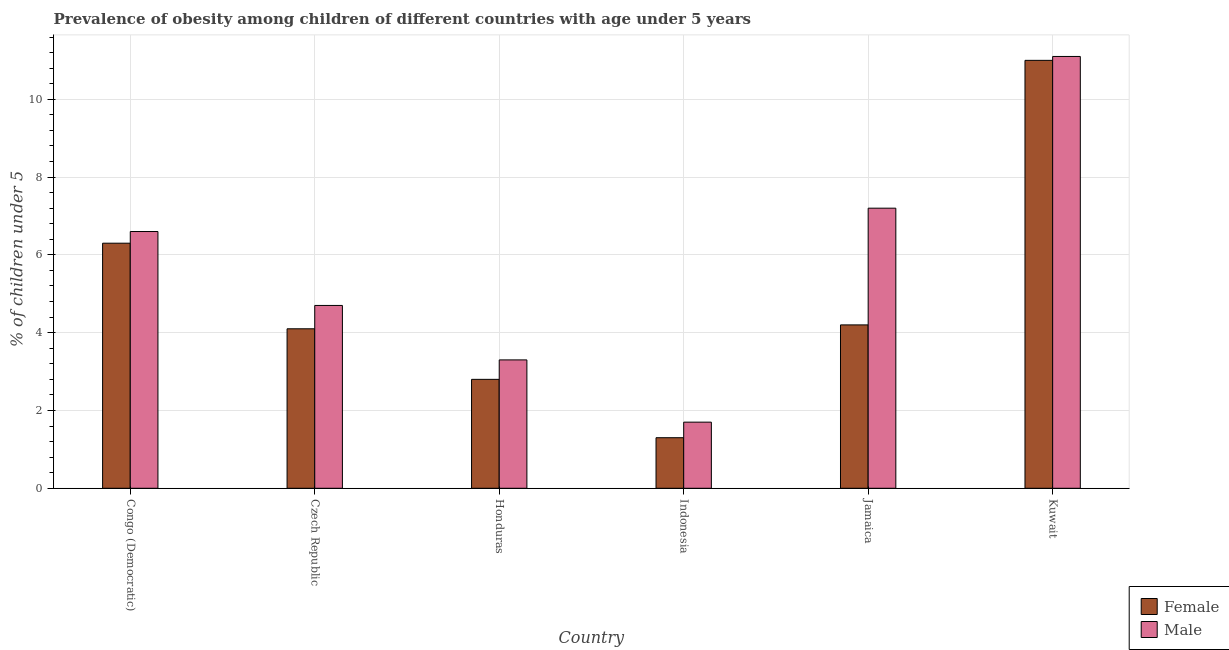How many groups of bars are there?
Provide a succinct answer. 6. Are the number of bars on each tick of the X-axis equal?
Your response must be concise. Yes. What is the label of the 1st group of bars from the left?
Provide a succinct answer. Congo (Democratic). What is the percentage of obese female children in Jamaica?
Keep it short and to the point. 4.2. Across all countries, what is the maximum percentage of obese male children?
Offer a very short reply. 11.1. Across all countries, what is the minimum percentage of obese male children?
Your answer should be compact. 1.7. In which country was the percentage of obese female children maximum?
Provide a short and direct response. Kuwait. What is the total percentage of obese female children in the graph?
Offer a terse response. 29.7. What is the difference between the percentage of obese male children in Czech Republic and that in Honduras?
Make the answer very short. 1.4. What is the difference between the percentage of obese male children in Congo (Democratic) and the percentage of obese female children in Jamaica?
Offer a very short reply. 2.4. What is the average percentage of obese female children per country?
Provide a short and direct response. 4.95. What is the difference between the percentage of obese male children and percentage of obese female children in Kuwait?
Give a very brief answer. 0.1. What is the ratio of the percentage of obese male children in Czech Republic to that in Honduras?
Give a very brief answer. 1.42. Is the percentage of obese male children in Honduras less than that in Jamaica?
Provide a short and direct response. Yes. Is the difference between the percentage of obese male children in Indonesia and Kuwait greater than the difference between the percentage of obese female children in Indonesia and Kuwait?
Provide a short and direct response. Yes. What is the difference between the highest and the second highest percentage of obese male children?
Your answer should be very brief. 3.9. What is the difference between the highest and the lowest percentage of obese female children?
Provide a short and direct response. 9.7. In how many countries, is the percentage of obese female children greater than the average percentage of obese female children taken over all countries?
Provide a short and direct response. 2. Is the sum of the percentage of obese female children in Congo (Democratic) and Indonesia greater than the maximum percentage of obese male children across all countries?
Offer a very short reply. No. What does the 1st bar from the left in Jamaica represents?
Give a very brief answer. Female. Does the graph contain any zero values?
Provide a succinct answer. No. How are the legend labels stacked?
Your response must be concise. Vertical. What is the title of the graph?
Your answer should be very brief. Prevalence of obesity among children of different countries with age under 5 years. What is the label or title of the X-axis?
Keep it short and to the point. Country. What is the label or title of the Y-axis?
Keep it short and to the point.  % of children under 5. What is the  % of children under 5 of Female in Congo (Democratic)?
Ensure brevity in your answer.  6.3. What is the  % of children under 5 of Male in Congo (Democratic)?
Make the answer very short. 6.6. What is the  % of children under 5 of Female in Czech Republic?
Your response must be concise. 4.1. What is the  % of children under 5 of Male in Czech Republic?
Provide a short and direct response. 4.7. What is the  % of children under 5 of Female in Honduras?
Offer a very short reply. 2.8. What is the  % of children under 5 in Male in Honduras?
Your response must be concise. 3.3. What is the  % of children under 5 in Female in Indonesia?
Your answer should be compact. 1.3. What is the  % of children under 5 in Male in Indonesia?
Your response must be concise. 1.7. What is the  % of children under 5 of Female in Jamaica?
Keep it short and to the point. 4.2. What is the  % of children under 5 in Male in Jamaica?
Offer a very short reply. 7.2. What is the  % of children under 5 of Female in Kuwait?
Your answer should be compact. 11. What is the  % of children under 5 in Male in Kuwait?
Provide a succinct answer. 11.1. Across all countries, what is the maximum  % of children under 5 in Male?
Make the answer very short. 11.1. Across all countries, what is the minimum  % of children under 5 of Female?
Your response must be concise. 1.3. Across all countries, what is the minimum  % of children under 5 in Male?
Make the answer very short. 1.7. What is the total  % of children under 5 in Female in the graph?
Offer a very short reply. 29.7. What is the total  % of children under 5 of Male in the graph?
Give a very brief answer. 34.6. What is the difference between the  % of children under 5 in Female in Congo (Democratic) and that in Czech Republic?
Keep it short and to the point. 2.2. What is the difference between the  % of children under 5 of Female in Congo (Democratic) and that in Honduras?
Offer a terse response. 3.5. What is the difference between the  % of children under 5 of Male in Congo (Democratic) and that in Indonesia?
Offer a terse response. 4.9. What is the difference between the  % of children under 5 of Male in Congo (Democratic) and that in Jamaica?
Your response must be concise. -0.6. What is the difference between the  % of children under 5 of Male in Congo (Democratic) and that in Kuwait?
Keep it short and to the point. -4.5. What is the difference between the  % of children under 5 in Male in Czech Republic and that in Honduras?
Provide a short and direct response. 1.4. What is the difference between the  % of children under 5 of Female in Czech Republic and that in Jamaica?
Offer a very short reply. -0.1. What is the difference between the  % of children under 5 in Male in Czech Republic and that in Jamaica?
Offer a very short reply. -2.5. What is the difference between the  % of children under 5 in Female in Honduras and that in Indonesia?
Give a very brief answer. 1.5. What is the difference between the  % of children under 5 of Male in Honduras and that in Indonesia?
Keep it short and to the point. 1.6. What is the difference between the  % of children under 5 in Male in Honduras and that in Jamaica?
Your response must be concise. -3.9. What is the difference between the  % of children under 5 in Female in Honduras and that in Kuwait?
Give a very brief answer. -8.2. What is the difference between the  % of children under 5 of Male in Indonesia and that in Jamaica?
Provide a short and direct response. -5.5. What is the difference between the  % of children under 5 of Female in Indonesia and that in Kuwait?
Your answer should be very brief. -9.7. What is the difference between the  % of children under 5 of Male in Indonesia and that in Kuwait?
Offer a terse response. -9.4. What is the difference between the  % of children under 5 in Male in Jamaica and that in Kuwait?
Offer a very short reply. -3.9. What is the difference between the  % of children under 5 of Female in Congo (Democratic) and the  % of children under 5 of Male in Indonesia?
Your answer should be very brief. 4.6. What is the difference between the  % of children under 5 in Female in Czech Republic and the  % of children under 5 in Male in Kuwait?
Your answer should be very brief. -7. What is the difference between the  % of children under 5 of Female in Honduras and the  % of children under 5 of Male in Indonesia?
Offer a terse response. 1.1. What is the average  % of children under 5 of Female per country?
Provide a succinct answer. 4.95. What is the average  % of children under 5 of Male per country?
Give a very brief answer. 5.77. What is the difference between the  % of children under 5 in Female and  % of children under 5 in Male in Congo (Democratic)?
Your response must be concise. -0.3. What is the difference between the  % of children under 5 in Female and  % of children under 5 in Male in Czech Republic?
Make the answer very short. -0.6. What is the difference between the  % of children under 5 in Female and  % of children under 5 in Male in Honduras?
Provide a short and direct response. -0.5. What is the difference between the  % of children under 5 in Female and  % of children under 5 in Male in Indonesia?
Offer a terse response. -0.4. What is the difference between the  % of children under 5 in Female and  % of children under 5 in Male in Jamaica?
Ensure brevity in your answer.  -3. What is the difference between the  % of children under 5 in Female and  % of children under 5 in Male in Kuwait?
Make the answer very short. -0.1. What is the ratio of the  % of children under 5 in Female in Congo (Democratic) to that in Czech Republic?
Provide a short and direct response. 1.54. What is the ratio of the  % of children under 5 in Male in Congo (Democratic) to that in Czech Republic?
Your answer should be compact. 1.4. What is the ratio of the  % of children under 5 of Female in Congo (Democratic) to that in Honduras?
Offer a very short reply. 2.25. What is the ratio of the  % of children under 5 of Female in Congo (Democratic) to that in Indonesia?
Your answer should be very brief. 4.85. What is the ratio of the  % of children under 5 in Male in Congo (Democratic) to that in Indonesia?
Your response must be concise. 3.88. What is the ratio of the  % of children under 5 in Female in Congo (Democratic) to that in Jamaica?
Provide a succinct answer. 1.5. What is the ratio of the  % of children under 5 of Male in Congo (Democratic) to that in Jamaica?
Ensure brevity in your answer.  0.92. What is the ratio of the  % of children under 5 of Female in Congo (Democratic) to that in Kuwait?
Offer a very short reply. 0.57. What is the ratio of the  % of children under 5 in Male in Congo (Democratic) to that in Kuwait?
Offer a terse response. 0.59. What is the ratio of the  % of children under 5 in Female in Czech Republic to that in Honduras?
Your answer should be compact. 1.46. What is the ratio of the  % of children under 5 in Male in Czech Republic to that in Honduras?
Keep it short and to the point. 1.42. What is the ratio of the  % of children under 5 of Female in Czech Republic to that in Indonesia?
Ensure brevity in your answer.  3.15. What is the ratio of the  % of children under 5 of Male in Czech Republic to that in Indonesia?
Make the answer very short. 2.76. What is the ratio of the  % of children under 5 of Female in Czech Republic to that in Jamaica?
Offer a terse response. 0.98. What is the ratio of the  % of children under 5 in Male in Czech Republic to that in Jamaica?
Keep it short and to the point. 0.65. What is the ratio of the  % of children under 5 of Female in Czech Republic to that in Kuwait?
Provide a short and direct response. 0.37. What is the ratio of the  % of children under 5 of Male in Czech Republic to that in Kuwait?
Give a very brief answer. 0.42. What is the ratio of the  % of children under 5 of Female in Honduras to that in Indonesia?
Give a very brief answer. 2.15. What is the ratio of the  % of children under 5 in Male in Honduras to that in Indonesia?
Keep it short and to the point. 1.94. What is the ratio of the  % of children under 5 in Female in Honduras to that in Jamaica?
Offer a very short reply. 0.67. What is the ratio of the  % of children under 5 in Male in Honduras to that in Jamaica?
Provide a short and direct response. 0.46. What is the ratio of the  % of children under 5 of Female in Honduras to that in Kuwait?
Your response must be concise. 0.25. What is the ratio of the  % of children under 5 in Male in Honduras to that in Kuwait?
Give a very brief answer. 0.3. What is the ratio of the  % of children under 5 in Female in Indonesia to that in Jamaica?
Your response must be concise. 0.31. What is the ratio of the  % of children under 5 in Male in Indonesia to that in Jamaica?
Ensure brevity in your answer.  0.24. What is the ratio of the  % of children under 5 in Female in Indonesia to that in Kuwait?
Make the answer very short. 0.12. What is the ratio of the  % of children under 5 of Male in Indonesia to that in Kuwait?
Your answer should be compact. 0.15. What is the ratio of the  % of children under 5 in Female in Jamaica to that in Kuwait?
Offer a very short reply. 0.38. What is the ratio of the  % of children under 5 of Male in Jamaica to that in Kuwait?
Provide a succinct answer. 0.65. What is the difference between the highest and the second highest  % of children under 5 in Female?
Ensure brevity in your answer.  4.7. 